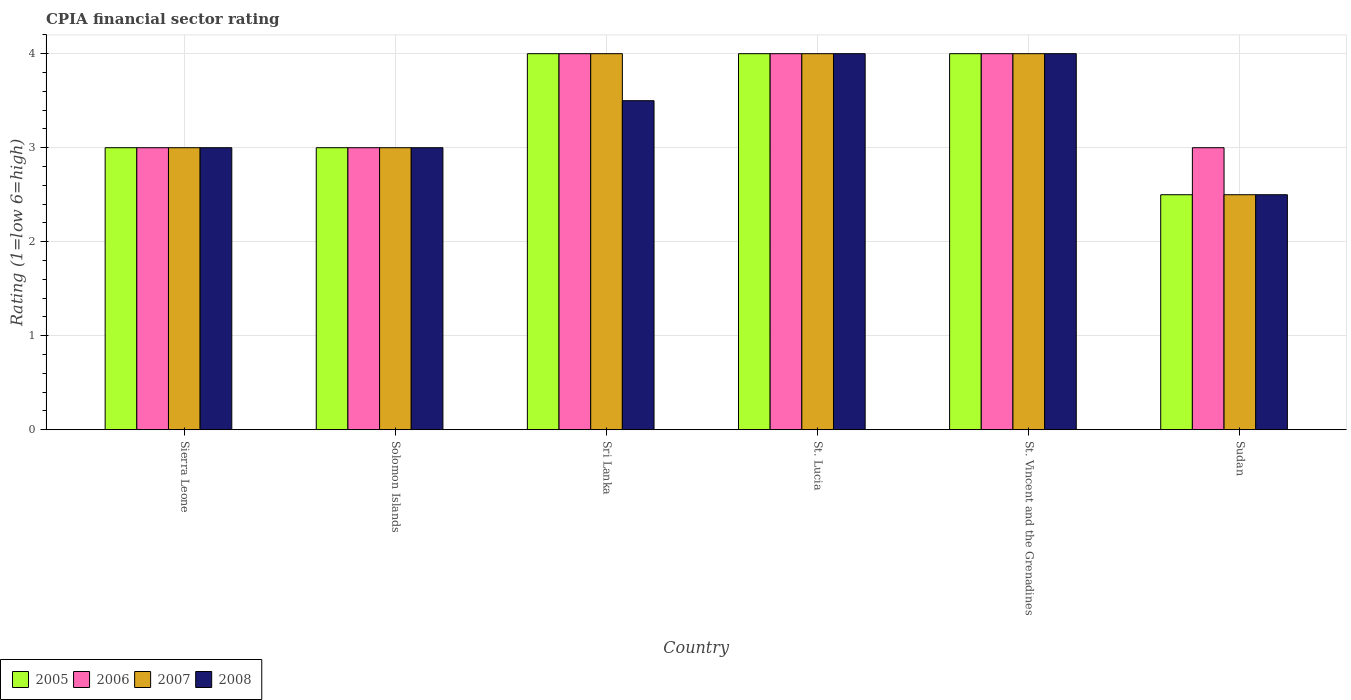How many groups of bars are there?
Provide a succinct answer. 6. How many bars are there on the 4th tick from the right?
Keep it short and to the point. 4. What is the label of the 1st group of bars from the left?
Provide a short and direct response. Sierra Leone. What is the CPIA rating in 2007 in Solomon Islands?
Keep it short and to the point. 3. In which country was the CPIA rating in 2008 maximum?
Your answer should be very brief. St. Lucia. In which country was the CPIA rating in 2008 minimum?
Provide a succinct answer. Sudan. What is the difference between the CPIA rating in 2007 in Solomon Islands and the CPIA rating in 2006 in Sri Lanka?
Keep it short and to the point. -1. What is the average CPIA rating in 2006 per country?
Your answer should be very brief. 3.5. What is the ratio of the CPIA rating in 2007 in Solomon Islands to that in Sri Lanka?
Offer a very short reply. 0.75. Is the CPIA rating in 2008 in St. Lucia less than that in St. Vincent and the Grenadines?
Keep it short and to the point. No. What is the difference between the highest and the second highest CPIA rating in 2008?
Provide a succinct answer. -0.5. What is the difference between the highest and the lowest CPIA rating in 2005?
Ensure brevity in your answer.  1.5. Is it the case that in every country, the sum of the CPIA rating in 2008 and CPIA rating in 2005 is greater than the sum of CPIA rating in 2007 and CPIA rating in 2006?
Offer a very short reply. No. What does the 3rd bar from the right in St. Lucia represents?
Your response must be concise. 2006. Is it the case that in every country, the sum of the CPIA rating in 2007 and CPIA rating in 2005 is greater than the CPIA rating in 2006?
Your answer should be very brief. Yes. How many bars are there?
Your response must be concise. 24. Are all the bars in the graph horizontal?
Your answer should be very brief. No. How many countries are there in the graph?
Your answer should be very brief. 6. Are the values on the major ticks of Y-axis written in scientific E-notation?
Your answer should be compact. No. Where does the legend appear in the graph?
Your answer should be compact. Bottom left. How many legend labels are there?
Your response must be concise. 4. What is the title of the graph?
Give a very brief answer. CPIA financial sector rating. What is the label or title of the X-axis?
Keep it short and to the point. Country. What is the Rating (1=low 6=high) in 2008 in Sierra Leone?
Ensure brevity in your answer.  3. What is the Rating (1=low 6=high) of 2006 in Solomon Islands?
Your answer should be compact. 3. What is the Rating (1=low 6=high) of 2005 in Sri Lanka?
Your answer should be compact. 4. What is the Rating (1=low 6=high) of 2008 in Sri Lanka?
Provide a short and direct response. 3.5. What is the Rating (1=low 6=high) of 2008 in St. Vincent and the Grenadines?
Make the answer very short. 4. What is the Rating (1=low 6=high) of 2006 in Sudan?
Your answer should be very brief. 3. What is the Rating (1=low 6=high) of 2007 in Sudan?
Make the answer very short. 2.5. What is the Rating (1=low 6=high) of 2008 in Sudan?
Your response must be concise. 2.5. Across all countries, what is the maximum Rating (1=low 6=high) in 2005?
Your response must be concise. 4. Across all countries, what is the maximum Rating (1=low 6=high) of 2008?
Your answer should be very brief. 4. Across all countries, what is the minimum Rating (1=low 6=high) of 2005?
Provide a short and direct response. 2.5. Across all countries, what is the minimum Rating (1=low 6=high) of 2006?
Offer a very short reply. 3. Across all countries, what is the minimum Rating (1=low 6=high) of 2007?
Ensure brevity in your answer.  2.5. What is the total Rating (1=low 6=high) in 2007 in the graph?
Your answer should be very brief. 20.5. What is the difference between the Rating (1=low 6=high) in 2005 in Sierra Leone and that in Sri Lanka?
Offer a terse response. -1. What is the difference between the Rating (1=low 6=high) of 2005 in Sierra Leone and that in St. Lucia?
Your answer should be very brief. -1. What is the difference between the Rating (1=low 6=high) of 2006 in Sierra Leone and that in St. Lucia?
Keep it short and to the point. -1. What is the difference between the Rating (1=low 6=high) of 2007 in Sierra Leone and that in St. Lucia?
Your answer should be compact. -1. What is the difference between the Rating (1=low 6=high) in 2005 in Sierra Leone and that in St. Vincent and the Grenadines?
Offer a very short reply. -1. What is the difference between the Rating (1=low 6=high) in 2006 in Sierra Leone and that in St. Vincent and the Grenadines?
Provide a succinct answer. -1. What is the difference between the Rating (1=low 6=high) in 2007 in Sierra Leone and that in St. Vincent and the Grenadines?
Your response must be concise. -1. What is the difference between the Rating (1=low 6=high) of 2006 in Sierra Leone and that in Sudan?
Offer a very short reply. 0. What is the difference between the Rating (1=low 6=high) of 2007 in Sierra Leone and that in Sudan?
Keep it short and to the point. 0.5. What is the difference between the Rating (1=low 6=high) in 2008 in Sierra Leone and that in Sudan?
Give a very brief answer. 0.5. What is the difference between the Rating (1=low 6=high) of 2006 in Solomon Islands and that in Sri Lanka?
Make the answer very short. -1. What is the difference between the Rating (1=low 6=high) of 2007 in Solomon Islands and that in Sri Lanka?
Your answer should be very brief. -1. What is the difference between the Rating (1=low 6=high) in 2008 in Solomon Islands and that in Sri Lanka?
Your answer should be compact. -0.5. What is the difference between the Rating (1=low 6=high) of 2006 in Solomon Islands and that in St. Lucia?
Offer a very short reply. -1. What is the difference between the Rating (1=low 6=high) in 2007 in Solomon Islands and that in St. Lucia?
Keep it short and to the point. -1. What is the difference between the Rating (1=low 6=high) of 2008 in Solomon Islands and that in St. Lucia?
Ensure brevity in your answer.  -1. What is the difference between the Rating (1=low 6=high) in 2007 in Solomon Islands and that in St. Vincent and the Grenadines?
Ensure brevity in your answer.  -1. What is the difference between the Rating (1=low 6=high) of 2007 in Solomon Islands and that in Sudan?
Your response must be concise. 0.5. What is the difference between the Rating (1=low 6=high) in 2005 in Sri Lanka and that in St. Lucia?
Give a very brief answer. 0. What is the difference between the Rating (1=low 6=high) in 2007 in Sri Lanka and that in St. Lucia?
Ensure brevity in your answer.  0. What is the difference between the Rating (1=low 6=high) in 2008 in Sri Lanka and that in St. Vincent and the Grenadines?
Offer a terse response. -0.5. What is the difference between the Rating (1=low 6=high) in 2007 in Sri Lanka and that in Sudan?
Ensure brevity in your answer.  1.5. What is the difference between the Rating (1=low 6=high) in 2008 in Sri Lanka and that in Sudan?
Offer a terse response. 1. What is the difference between the Rating (1=low 6=high) of 2005 in St. Lucia and that in St. Vincent and the Grenadines?
Your answer should be very brief. 0. What is the difference between the Rating (1=low 6=high) of 2006 in St. Lucia and that in St. Vincent and the Grenadines?
Your response must be concise. 0. What is the difference between the Rating (1=low 6=high) in 2007 in St. Lucia and that in St. Vincent and the Grenadines?
Offer a terse response. 0. What is the difference between the Rating (1=low 6=high) of 2008 in St. Lucia and that in St. Vincent and the Grenadines?
Your answer should be very brief. 0. What is the difference between the Rating (1=low 6=high) in 2007 in St. Lucia and that in Sudan?
Keep it short and to the point. 1.5. What is the difference between the Rating (1=low 6=high) in 2006 in St. Vincent and the Grenadines and that in Sudan?
Ensure brevity in your answer.  1. What is the difference between the Rating (1=low 6=high) of 2007 in St. Vincent and the Grenadines and that in Sudan?
Give a very brief answer. 1.5. What is the difference between the Rating (1=low 6=high) in 2008 in St. Vincent and the Grenadines and that in Sudan?
Offer a terse response. 1.5. What is the difference between the Rating (1=low 6=high) of 2005 in Sierra Leone and the Rating (1=low 6=high) of 2008 in Solomon Islands?
Your answer should be very brief. 0. What is the difference between the Rating (1=low 6=high) of 2005 in Sierra Leone and the Rating (1=low 6=high) of 2006 in Sri Lanka?
Your answer should be compact. -1. What is the difference between the Rating (1=low 6=high) in 2005 in Sierra Leone and the Rating (1=low 6=high) in 2008 in Sri Lanka?
Ensure brevity in your answer.  -0.5. What is the difference between the Rating (1=low 6=high) of 2007 in Sierra Leone and the Rating (1=low 6=high) of 2008 in Sri Lanka?
Make the answer very short. -0.5. What is the difference between the Rating (1=low 6=high) of 2005 in Sierra Leone and the Rating (1=low 6=high) of 2007 in St. Lucia?
Provide a succinct answer. -1. What is the difference between the Rating (1=low 6=high) in 2005 in Sierra Leone and the Rating (1=low 6=high) in 2008 in St. Lucia?
Ensure brevity in your answer.  -1. What is the difference between the Rating (1=low 6=high) of 2006 in Sierra Leone and the Rating (1=low 6=high) of 2007 in St. Lucia?
Keep it short and to the point. -1. What is the difference between the Rating (1=low 6=high) in 2007 in Sierra Leone and the Rating (1=low 6=high) in 2008 in St. Lucia?
Provide a succinct answer. -1. What is the difference between the Rating (1=low 6=high) of 2005 in Sierra Leone and the Rating (1=low 6=high) of 2006 in St. Vincent and the Grenadines?
Offer a very short reply. -1. What is the difference between the Rating (1=low 6=high) of 2005 in Sierra Leone and the Rating (1=low 6=high) of 2007 in St. Vincent and the Grenadines?
Make the answer very short. -1. What is the difference between the Rating (1=low 6=high) in 2005 in Sierra Leone and the Rating (1=low 6=high) in 2008 in St. Vincent and the Grenadines?
Keep it short and to the point. -1. What is the difference between the Rating (1=low 6=high) of 2006 in Sierra Leone and the Rating (1=low 6=high) of 2007 in St. Vincent and the Grenadines?
Keep it short and to the point. -1. What is the difference between the Rating (1=low 6=high) in 2006 in Sierra Leone and the Rating (1=low 6=high) in 2008 in St. Vincent and the Grenadines?
Give a very brief answer. -1. What is the difference between the Rating (1=low 6=high) of 2006 in Sierra Leone and the Rating (1=low 6=high) of 2008 in Sudan?
Offer a terse response. 0.5. What is the difference between the Rating (1=low 6=high) in 2005 in Solomon Islands and the Rating (1=low 6=high) in 2007 in Sri Lanka?
Provide a short and direct response. -1. What is the difference between the Rating (1=low 6=high) in 2006 in Solomon Islands and the Rating (1=low 6=high) in 2007 in Sri Lanka?
Give a very brief answer. -1. What is the difference between the Rating (1=low 6=high) of 2007 in Solomon Islands and the Rating (1=low 6=high) of 2008 in St. Lucia?
Your answer should be compact. -1. What is the difference between the Rating (1=low 6=high) in 2007 in Solomon Islands and the Rating (1=low 6=high) in 2008 in St. Vincent and the Grenadines?
Your answer should be very brief. -1. What is the difference between the Rating (1=low 6=high) of 2005 in Solomon Islands and the Rating (1=low 6=high) of 2006 in Sudan?
Make the answer very short. 0. What is the difference between the Rating (1=low 6=high) of 2005 in Solomon Islands and the Rating (1=low 6=high) of 2007 in Sudan?
Give a very brief answer. 0.5. What is the difference between the Rating (1=low 6=high) of 2006 in Solomon Islands and the Rating (1=low 6=high) of 2007 in Sudan?
Offer a terse response. 0.5. What is the difference between the Rating (1=low 6=high) of 2006 in Solomon Islands and the Rating (1=low 6=high) of 2008 in Sudan?
Your answer should be very brief. 0.5. What is the difference between the Rating (1=low 6=high) in 2007 in Solomon Islands and the Rating (1=low 6=high) in 2008 in Sudan?
Offer a terse response. 0.5. What is the difference between the Rating (1=low 6=high) in 2006 in Sri Lanka and the Rating (1=low 6=high) in 2007 in St. Lucia?
Keep it short and to the point. 0. What is the difference between the Rating (1=low 6=high) in 2006 in Sri Lanka and the Rating (1=low 6=high) in 2008 in St. Lucia?
Offer a very short reply. 0. What is the difference between the Rating (1=low 6=high) of 2005 in Sri Lanka and the Rating (1=low 6=high) of 2007 in St. Vincent and the Grenadines?
Ensure brevity in your answer.  0. What is the difference between the Rating (1=low 6=high) in 2006 in Sri Lanka and the Rating (1=low 6=high) in 2007 in St. Vincent and the Grenadines?
Ensure brevity in your answer.  0. What is the difference between the Rating (1=low 6=high) in 2007 in Sri Lanka and the Rating (1=low 6=high) in 2008 in St. Vincent and the Grenadines?
Make the answer very short. 0. What is the difference between the Rating (1=low 6=high) in 2005 in Sri Lanka and the Rating (1=low 6=high) in 2006 in Sudan?
Your answer should be very brief. 1. What is the difference between the Rating (1=low 6=high) of 2005 in Sri Lanka and the Rating (1=low 6=high) of 2007 in Sudan?
Provide a succinct answer. 1.5. What is the difference between the Rating (1=low 6=high) in 2005 in Sri Lanka and the Rating (1=low 6=high) in 2008 in Sudan?
Offer a very short reply. 1.5. What is the difference between the Rating (1=low 6=high) in 2006 in Sri Lanka and the Rating (1=low 6=high) in 2007 in Sudan?
Your answer should be compact. 1.5. What is the difference between the Rating (1=low 6=high) in 2006 in Sri Lanka and the Rating (1=low 6=high) in 2008 in Sudan?
Give a very brief answer. 1.5. What is the difference between the Rating (1=low 6=high) in 2005 in St. Lucia and the Rating (1=low 6=high) in 2007 in St. Vincent and the Grenadines?
Give a very brief answer. 0. What is the difference between the Rating (1=low 6=high) of 2005 in St. Lucia and the Rating (1=low 6=high) of 2006 in Sudan?
Your answer should be compact. 1. What is the difference between the Rating (1=low 6=high) in 2005 in St. Lucia and the Rating (1=low 6=high) in 2008 in Sudan?
Provide a succinct answer. 1.5. What is the difference between the Rating (1=low 6=high) in 2006 in St. Lucia and the Rating (1=low 6=high) in 2008 in Sudan?
Provide a short and direct response. 1.5. What is the difference between the Rating (1=low 6=high) of 2007 in St. Lucia and the Rating (1=low 6=high) of 2008 in Sudan?
Offer a terse response. 1.5. What is the difference between the Rating (1=low 6=high) of 2005 in St. Vincent and the Grenadines and the Rating (1=low 6=high) of 2006 in Sudan?
Give a very brief answer. 1. What is the difference between the Rating (1=low 6=high) of 2007 in St. Vincent and the Grenadines and the Rating (1=low 6=high) of 2008 in Sudan?
Your answer should be compact. 1.5. What is the average Rating (1=low 6=high) of 2005 per country?
Provide a succinct answer. 3.42. What is the average Rating (1=low 6=high) of 2006 per country?
Offer a terse response. 3.5. What is the average Rating (1=low 6=high) of 2007 per country?
Provide a succinct answer. 3.42. What is the average Rating (1=low 6=high) in 2008 per country?
Your answer should be compact. 3.33. What is the difference between the Rating (1=low 6=high) in 2005 and Rating (1=low 6=high) in 2007 in Sierra Leone?
Offer a terse response. 0. What is the difference between the Rating (1=low 6=high) of 2005 and Rating (1=low 6=high) of 2008 in Sierra Leone?
Your answer should be compact. 0. What is the difference between the Rating (1=low 6=high) in 2006 and Rating (1=low 6=high) in 2007 in Sierra Leone?
Offer a terse response. 0. What is the difference between the Rating (1=low 6=high) in 2007 and Rating (1=low 6=high) in 2008 in Sierra Leone?
Your response must be concise. 0. What is the difference between the Rating (1=low 6=high) in 2005 and Rating (1=low 6=high) in 2006 in Solomon Islands?
Your response must be concise. 0. What is the difference between the Rating (1=low 6=high) in 2005 and Rating (1=low 6=high) in 2007 in Solomon Islands?
Make the answer very short. 0. What is the difference between the Rating (1=low 6=high) in 2005 and Rating (1=low 6=high) in 2008 in Solomon Islands?
Your answer should be very brief. 0. What is the difference between the Rating (1=low 6=high) in 2006 and Rating (1=low 6=high) in 2008 in Solomon Islands?
Offer a very short reply. 0. What is the difference between the Rating (1=low 6=high) of 2005 and Rating (1=low 6=high) of 2006 in Sri Lanka?
Your response must be concise. 0. What is the difference between the Rating (1=low 6=high) in 2005 and Rating (1=low 6=high) in 2008 in Sri Lanka?
Your answer should be compact. 0.5. What is the difference between the Rating (1=low 6=high) in 2006 and Rating (1=low 6=high) in 2007 in Sri Lanka?
Offer a very short reply. 0. What is the difference between the Rating (1=low 6=high) of 2006 and Rating (1=low 6=high) of 2008 in St. Lucia?
Make the answer very short. 0. What is the difference between the Rating (1=low 6=high) in 2007 and Rating (1=low 6=high) in 2008 in St. Lucia?
Offer a very short reply. 0. What is the difference between the Rating (1=low 6=high) in 2005 and Rating (1=low 6=high) in 2008 in St. Vincent and the Grenadines?
Give a very brief answer. 0. What is the difference between the Rating (1=low 6=high) in 2006 and Rating (1=low 6=high) in 2007 in St. Vincent and the Grenadines?
Keep it short and to the point. 0. What is the difference between the Rating (1=low 6=high) of 2006 and Rating (1=low 6=high) of 2008 in St. Vincent and the Grenadines?
Your response must be concise. 0. What is the difference between the Rating (1=low 6=high) of 2006 and Rating (1=low 6=high) of 2008 in Sudan?
Provide a short and direct response. 0.5. What is the difference between the Rating (1=low 6=high) in 2007 and Rating (1=low 6=high) in 2008 in Sudan?
Offer a terse response. 0. What is the ratio of the Rating (1=low 6=high) of 2005 in Sierra Leone to that in Solomon Islands?
Offer a terse response. 1. What is the ratio of the Rating (1=low 6=high) in 2005 in Sierra Leone to that in Sri Lanka?
Your response must be concise. 0.75. What is the ratio of the Rating (1=low 6=high) of 2007 in Sierra Leone to that in Sri Lanka?
Ensure brevity in your answer.  0.75. What is the ratio of the Rating (1=low 6=high) in 2005 in Sierra Leone to that in St. Lucia?
Make the answer very short. 0.75. What is the ratio of the Rating (1=low 6=high) in 2007 in Sierra Leone to that in St. Lucia?
Keep it short and to the point. 0.75. What is the ratio of the Rating (1=low 6=high) of 2005 in Sierra Leone to that in St. Vincent and the Grenadines?
Your response must be concise. 0.75. What is the ratio of the Rating (1=low 6=high) of 2008 in Sierra Leone to that in St. Vincent and the Grenadines?
Keep it short and to the point. 0.75. What is the ratio of the Rating (1=low 6=high) of 2006 in Sierra Leone to that in Sudan?
Ensure brevity in your answer.  1. What is the ratio of the Rating (1=low 6=high) of 2007 in Sierra Leone to that in Sudan?
Keep it short and to the point. 1.2. What is the ratio of the Rating (1=low 6=high) of 2005 in Solomon Islands to that in Sri Lanka?
Ensure brevity in your answer.  0.75. What is the ratio of the Rating (1=low 6=high) in 2008 in Solomon Islands to that in St. Lucia?
Keep it short and to the point. 0.75. What is the ratio of the Rating (1=low 6=high) in 2005 in Solomon Islands to that in St. Vincent and the Grenadines?
Make the answer very short. 0.75. What is the ratio of the Rating (1=low 6=high) in 2006 in Solomon Islands to that in Sudan?
Offer a very short reply. 1. What is the ratio of the Rating (1=low 6=high) of 2008 in Solomon Islands to that in Sudan?
Keep it short and to the point. 1.2. What is the ratio of the Rating (1=low 6=high) of 2005 in Sri Lanka to that in St. Lucia?
Provide a succinct answer. 1. What is the ratio of the Rating (1=low 6=high) in 2008 in Sri Lanka to that in St. Lucia?
Keep it short and to the point. 0.88. What is the ratio of the Rating (1=low 6=high) of 2005 in Sri Lanka to that in St. Vincent and the Grenadines?
Give a very brief answer. 1. What is the ratio of the Rating (1=low 6=high) in 2007 in Sri Lanka to that in St. Vincent and the Grenadines?
Make the answer very short. 1. What is the ratio of the Rating (1=low 6=high) of 2007 in Sri Lanka to that in Sudan?
Your answer should be very brief. 1.6. What is the ratio of the Rating (1=low 6=high) of 2008 in Sri Lanka to that in Sudan?
Offer a very short reply. 1.4. What is the ratio of the Rating (1=low 6=high) in 2005 in St. Lucia to that in St. Vincent and the Grenadines?
Your answer should be compact. 1. What is the ratio of the Rating (1=low 6=high) in 2006 in St. Lucia to that in St. Vincent and the Grenadines?
Offer a very short reply. 1. What is the ratio of the Rating (1=low 6=high) of 2007 in St. Lucia to that in St. Vincent and the Grenadines?
Ensure brevity in your answer.  1. What is the ratio of the Rating (1=low 6=high) of 2008 in St. Lucia to that in St. Vincent and the Grenadines?
Your answer should be compact. 1. What is the ratio of the Rating (1=low 6=high) of 2005 in St. Lucia to that in Sudan?
Give a very brief answer. 1.6. What is the ratio of the Rating (1=low 6=high) in 2008 in St. Lucia to that in Sudan?
Provide a short and direct response. 1.6. What is the ratio of the Rating (1=low 6=high) of 2006 in St. Vincent and the Grenadines to that in Sudan?
Make the answer very short. 1.33. What is the ratio of the Rating (1=low 6=high) of 2007 in St. Vincent and the Grenadines to that in Sudan?
Offer a very short reply. 1.6. What is the ratio of the Rating (1=low 6=high) of 2008 in St. Vincent and the Grenadines to that in Sudan?
Your response must be concise. 1.6. What is the difference between the highest and the second highest Rating (1=low 6=high) of 2005?
Make the answer very short. 0. What is the difference between the highest and the second highest Rating (1=low 6=high) in 2006?
Provide a succinct answer. 0. What is the difference between the highest and the second highest Rating (1=low 6=high) in 2007?
Your response must be concise. 0. What is the difference between the highest and the second highest Rating (1=low 6=high) in 2008?
Offer a terse response. 0. What is the difference between the highest and the lowest Rating (1=low 6=high) in 2006?
Provide a short and direct response. 1. What is the difference between the highest and the lowest Rating (1=low 6=high) in 2008?
Provide a succinct answer. 1.5. 